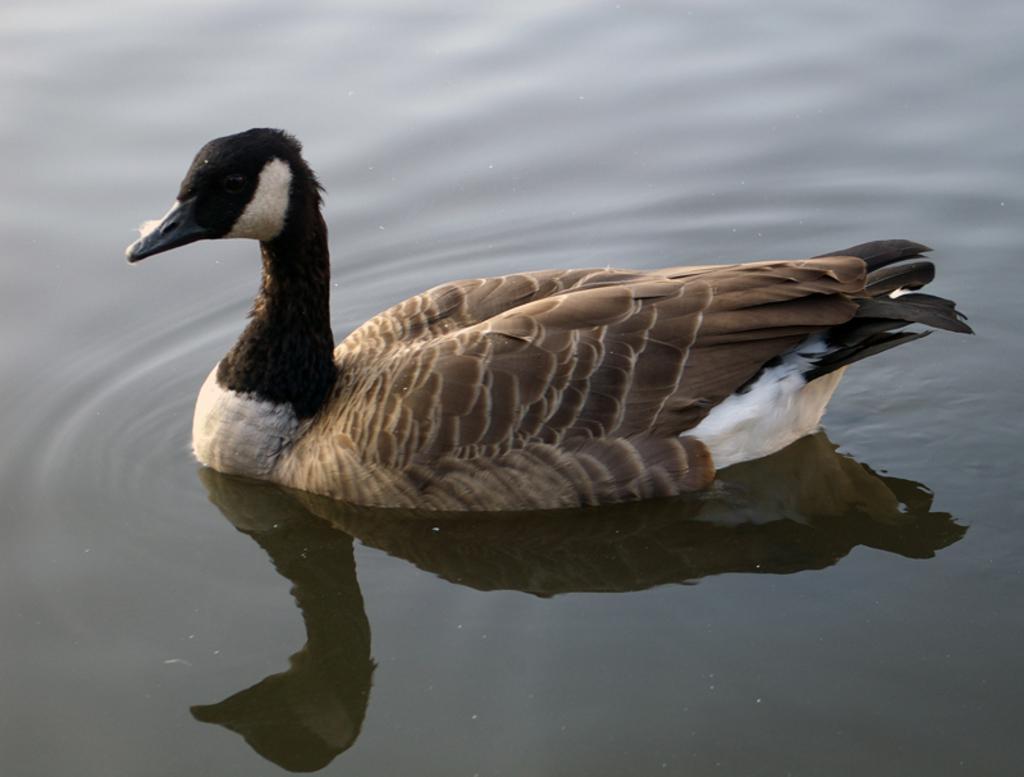How would you summarize this image in a sentence or two? In this picture I can see there is a duck swimming in the water and it has some brown feathers. 